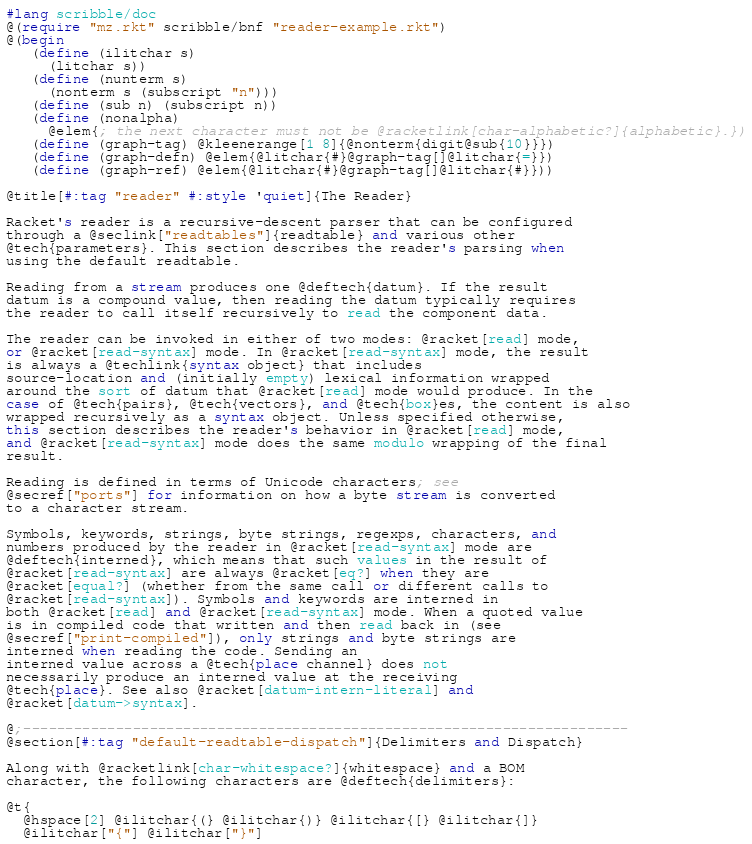<code> <loc_0><loc_0><loc_500><loc_500><_Racket_>#lang scribble/doc
@(require "mz.rkt" scribble/bnf "reader-example.rkt")
@(begin
   (define (ilitchar s)
     (litchar s))
   (define (nunterm s)
     (nonterm s (subscript "n")))
   (define (sub n) (subscript n))
   (define (nonalpha)
     @elem{; the next character must not be @racketlink[char-alphabetic?]{alphabetic}.})
   (define (graph-tag) @kleenerange[1 8]{@nonterm{digit@sub{10}}})
   (define (graph-defn) @elem{@litchar{#}@graph-tag[]@litchar{=}})
   (define (graph-ref) @elem{@litchar{#}@graph-tag[]@litchar{#}}))

@title[#:tag "reader" #:style 'quiet]{The Reader}

Racket's reader is a recursive-descent parser that can be configured
through a @seclink["readtables"]{readtable} and various other
@tech{parameters}. This section describes the reader's parsing when
using the default readtable.

Reading from a stream produces one @deftech{datum}. If the result
datum is a compound value, then reading the datum typically requires
the reader to call itself recursively to read the component data.

The reader can be invoked in either of two modes: @racket[read] mode,
or @racket[read-syntax] mode. In @racket[read-syntax] mode, the result
is always a @techlink{syntax object} that includes
source-location and (initially empty) lexical information wrapped
around the sort of datum that @racket[read] mode would produce. In the
case of @tech{pairs}, @tech{vectors}, and @tech{box}es, the content is also
wrapped recursively as a syntax object. Unless specified otherwise,
this section describes the reader's behavior in @racket[read] mode,
and @racket[read-syntax] mode does the same modulo wrapping of the final
result.

Reading is defined in terms of Unicode characters; see
@secref["ports"] for information on how a byte stream is converted
to a character stream.

Symbols, keywords, strings, byte strings, regexps, characters, and
numbers produced by the reader in @racket[read-syntax] mode are
@deftech{interned}, which means that such values in the result of
@racket[read-syntax] are always @racket[eq?] when they are
@racket[equal?] (whether from the same call or different calls to
@racket[read-syntax]). Symbols and keywords are interned in
both @racket[read] and @racket[read-syntax] mode. When a quoted value
is in compiled code that written and then read back in (see
@secref["print-compiled"]), only strings and byte strings are
interned when reading the code. Sending an
interned value across a @tech{place channel} does not
necessarily produce an interned value at the receiving
@tech{place}. See also @racket[datum-intern-literal] and
@racket[datum->syntax].

@;------------------------------------------------------------------------
@section[#:tag "default-readtable-dispatch"]{Delimiters and Dispatch}

Along with @racketlink[char-whitespace?]{whitespace} and a BOM
character, the following characters are @deftech{delimiters}:

@t{
  @hspace[2] @ilitchar{(} @ilitchar{)} @ilitchar{[} @ilitchar{]}
  @ilitchar["{"] @ilitchar["}"]</code> 